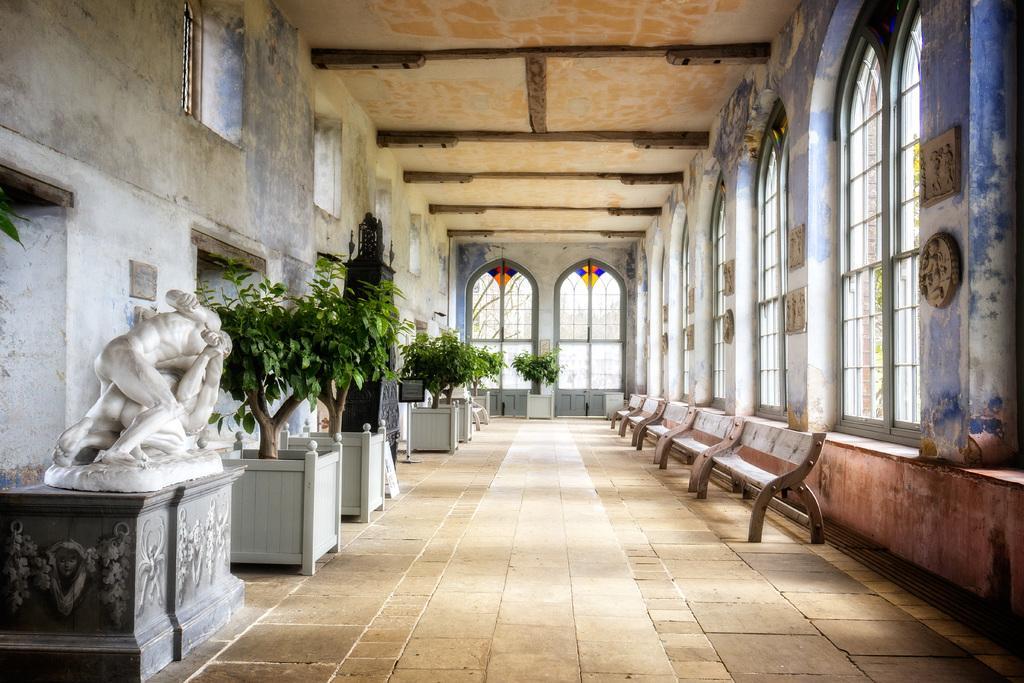Describe this image in one or two sentences. This picture is clicked inside. On the right we can see the benches. On the left we can see the house plants and the sculptures. At the top there is a roof, windows and walls. 